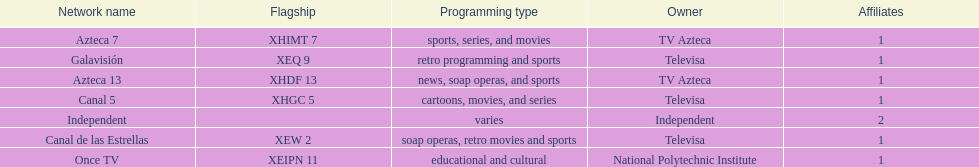Azteca 7 and azteca 13 are both owned by whom? TV Azteca. 